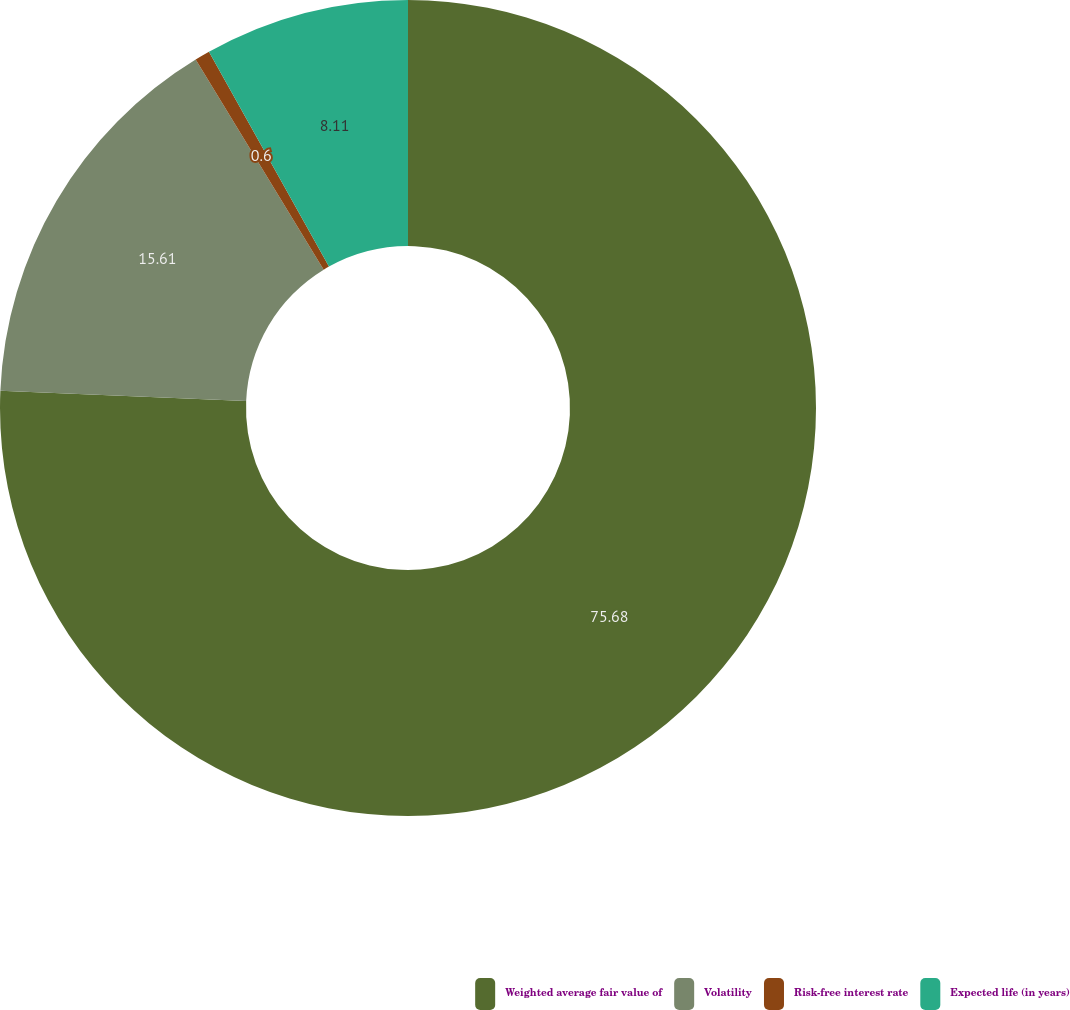<chart> <loc_0><loc_0><loc_500><loc_500><pie_chart><fcel>Weighted average fair value of<fcel>Volatility<fcel>Risk-free interest rate<fcel>Expected life (in years)<nl><fcel>75.67%<fcel>15.61%<fcel>0.6%<fcel>8.11%<nl></chart> 